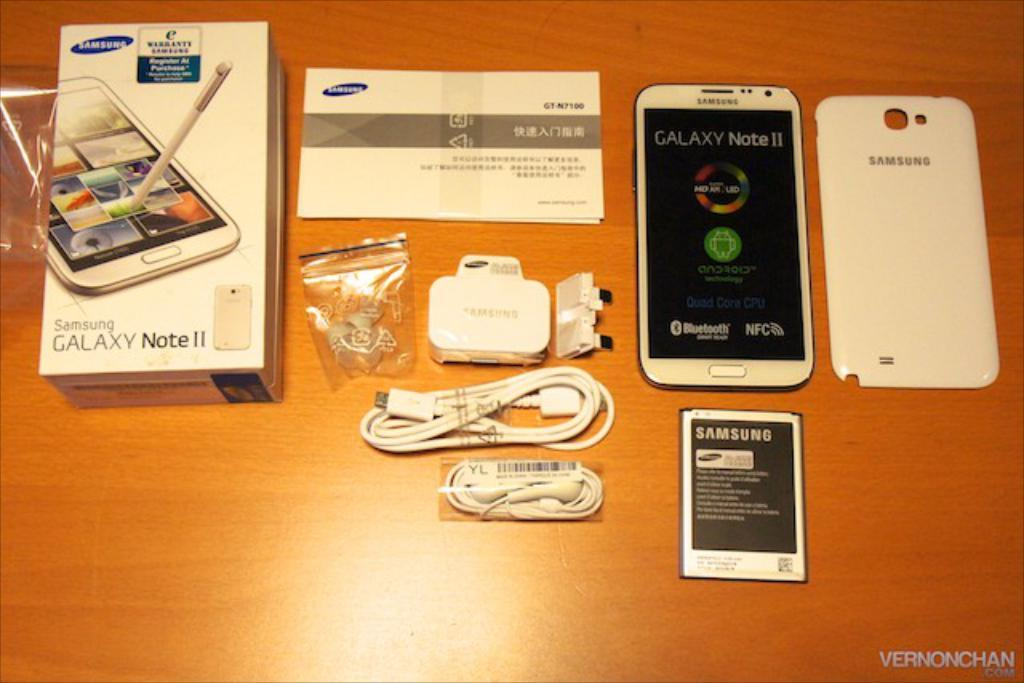Provide a one-sentence caption for the provided image. A Samsung Galaxy Note 2 with accessories on a table. 